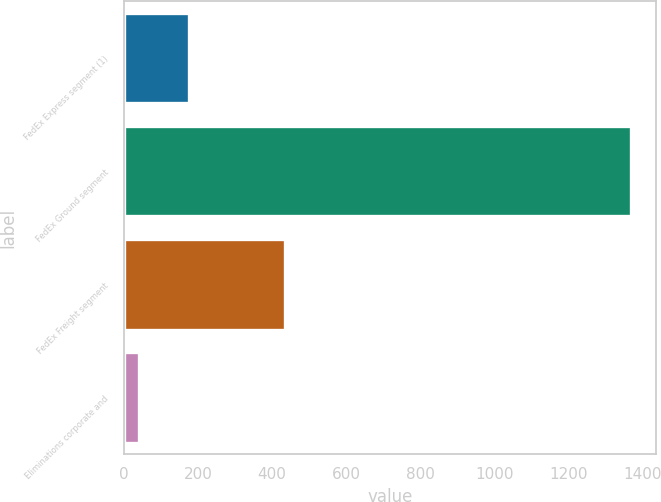Convert chart. <chart><loc_0><loc_0><loc_500><loc_500><bar_chart><fcel>FedEx Express segment (1)<fcel>FedEx Ground segment<fcel>FedEx Freight segment<fcel>Eliminations corporate and<nl><fcel>174.5<fcel>1367<fcel>434<fcel>42<nl></chart> 